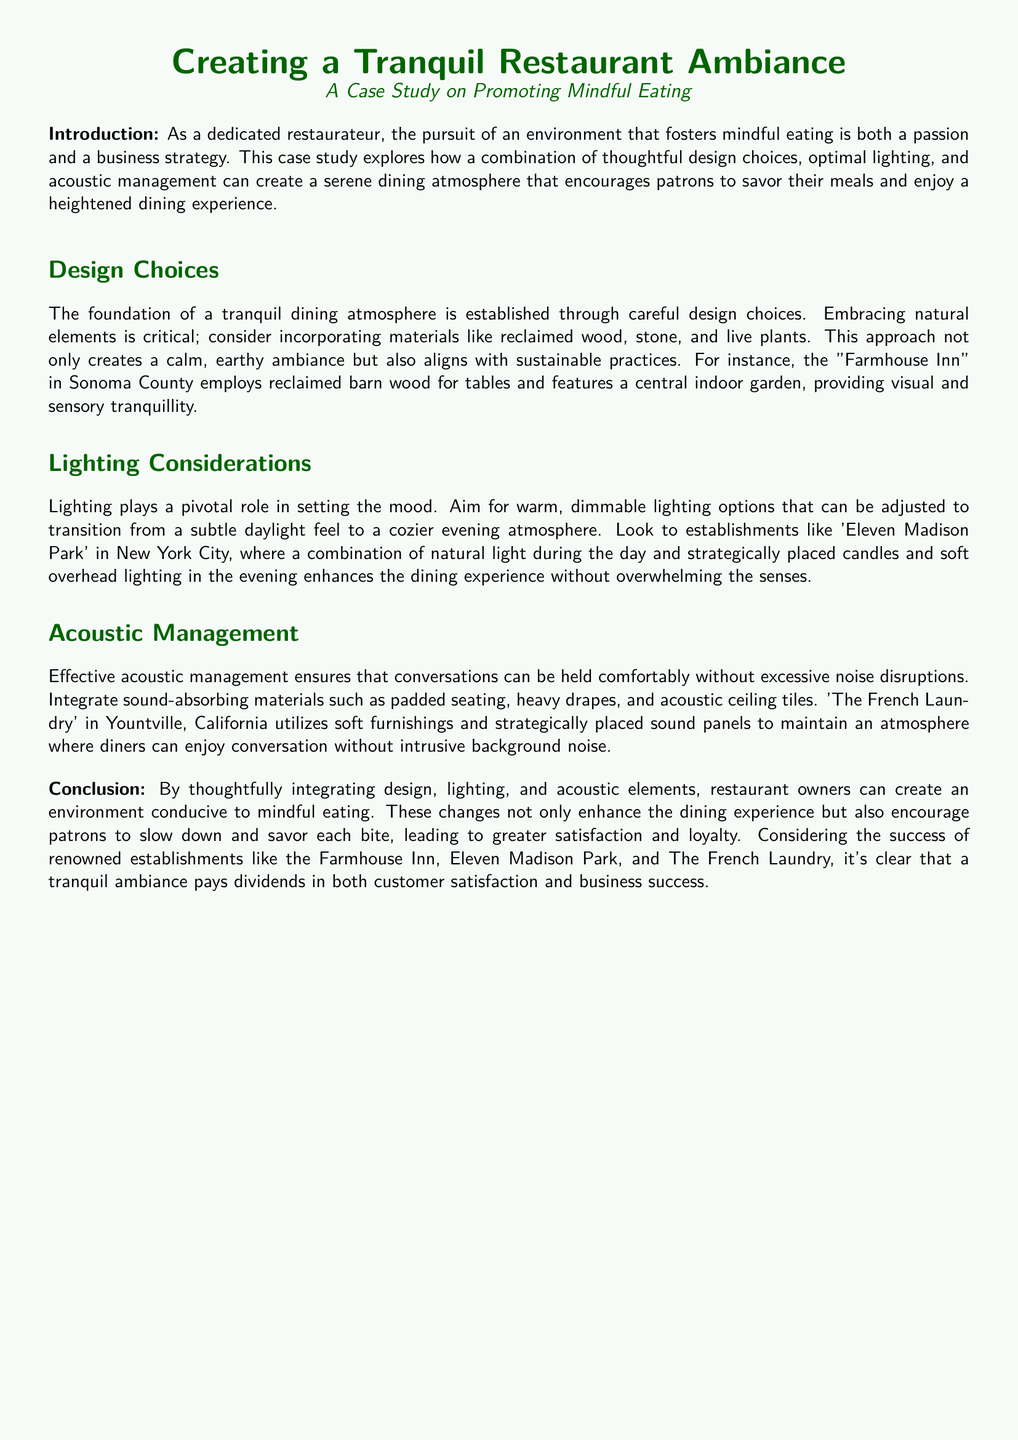What is the case study about? The case study explores how a combination of thoughtful design choices, optimal lighting, and acoustic management can create a serene dining atmosphere that encourages patrons to savor their meals and enjoy a heightened dining experience.
Answer: Promoting mindful eating What materials are suggested for creating a calm ambiance? The document advises incorporating materials like reclaimed wood, stone, and live plants to establish a tranquil dining atmosphere.
Answer: Reclaimed wood, stone, live plants Which restaurant uses reclaimed barn wood? The case study mentions "Farmhouse Inn" in Sonoma County as employing reclaimed barn wood for tables.
Answer: Farmhouse Inn What type of lighting is recommended? The document recommends warm, dimmable lighting options that transition from a subtle daylight feel to a cozier evening atmosphere.
Answer: Warm, dimmable lighting What acoustic management strategy is mentioned? The case study suggests integrating sound-absorbing materials such as padded seating, heavy drapes, and acoustic ceiling tiles for effective acoustic management.
Answer: Sound-absorbing materials Where is Eleven Madison Park located? The case study specifically references that Eleven Madison Park is in New York City.
Answer: New York City What effect does the tranquil ambiance aim for in diners? The document states that a tranquil ambiance encourages patrons to slow down and savor each bite.
Answer: To savor each bite What is the primary focus of the case study? The focus of the case study is on creating a tranquil restaurant ambiance that promotes mindful eating.
Answer: Tranquil restaurant ambiance 